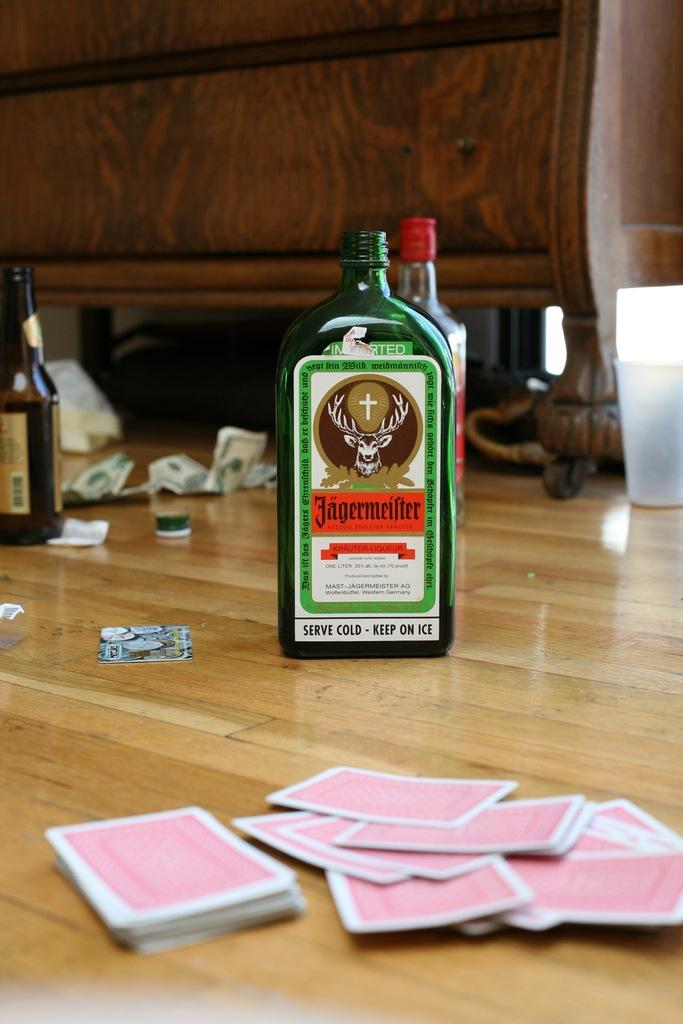<image>
Summarize the visual content of the image. a bottle that has the words serve cold on it 